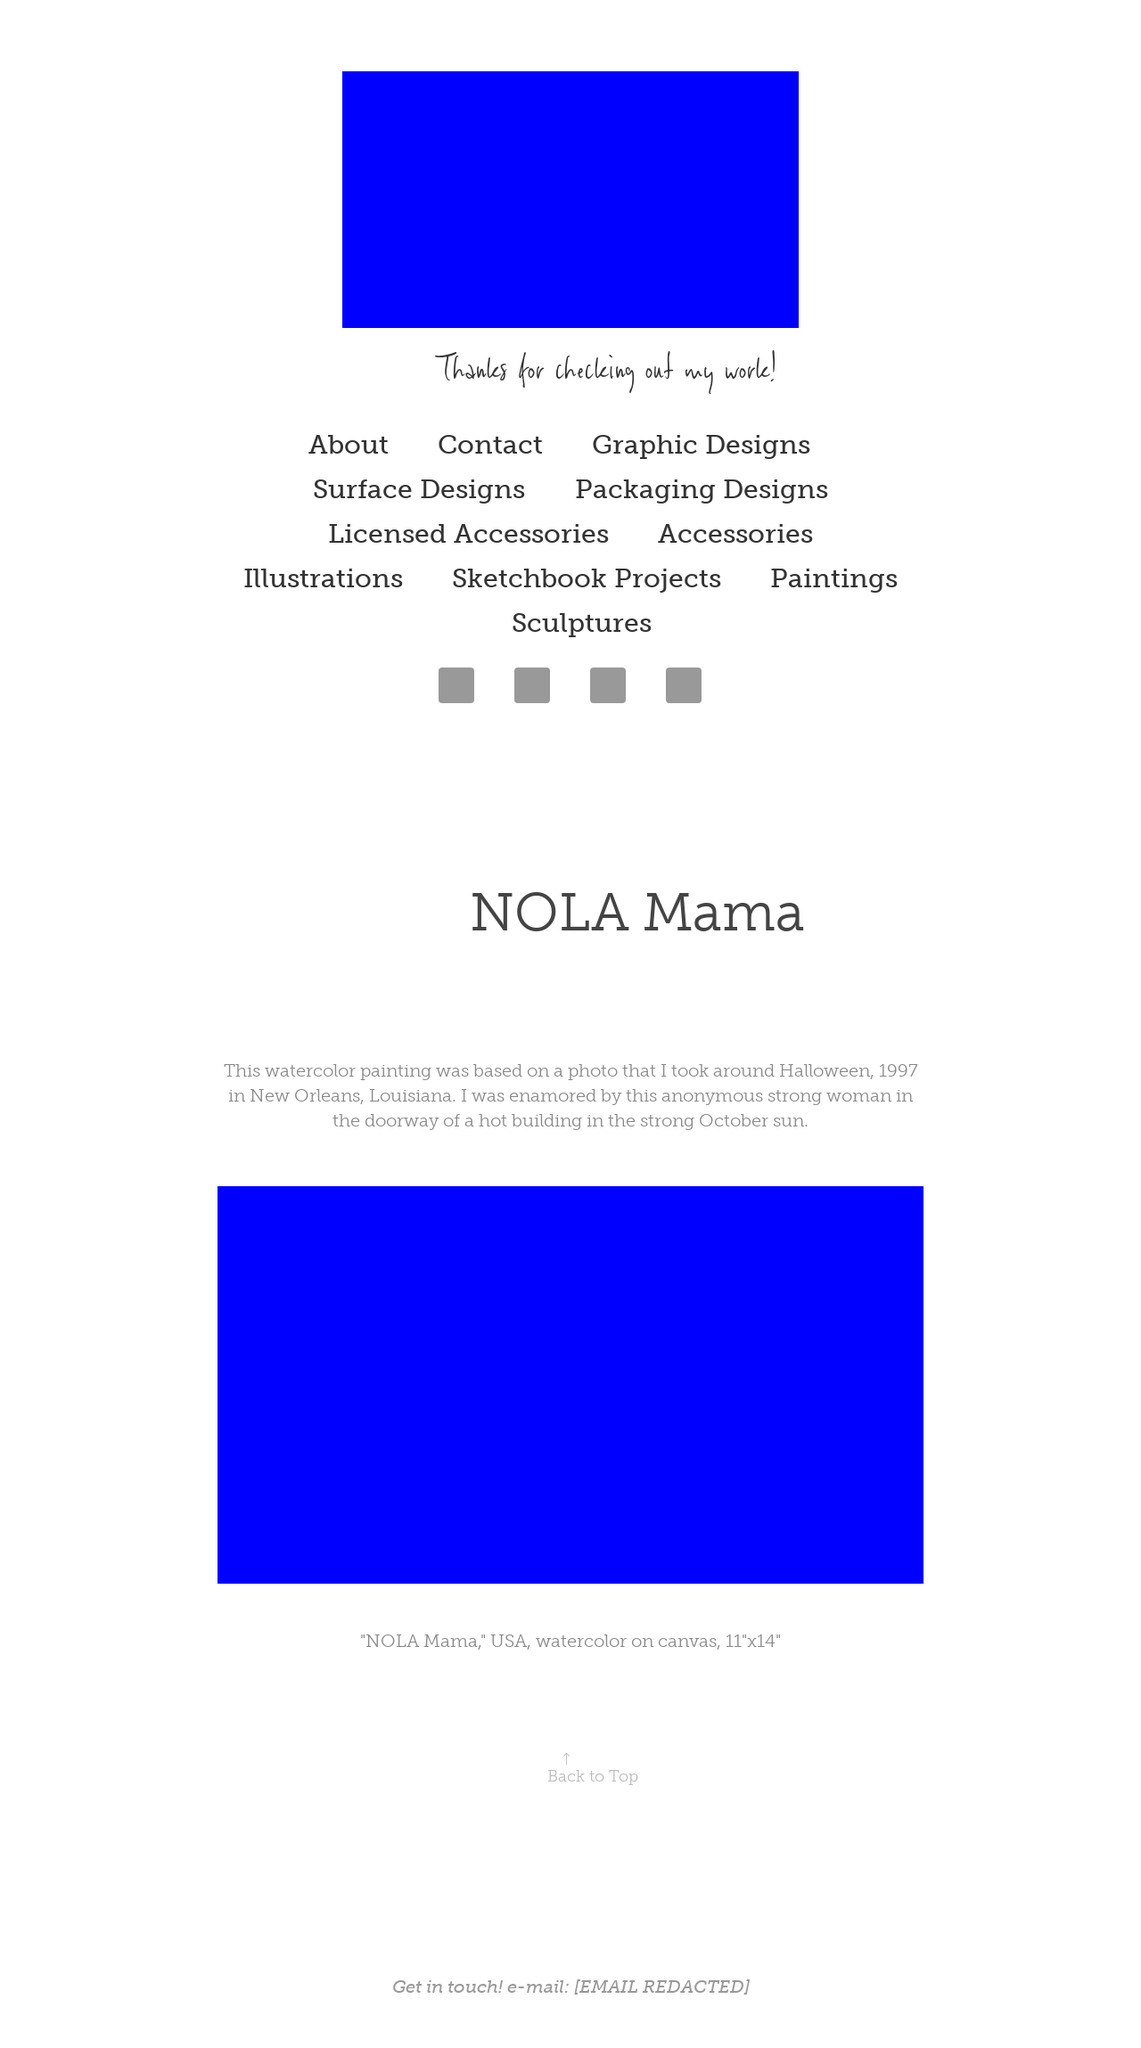What's the significance of preserving the story of 'NOLA Mama' on this website? Preserving the 'NOLA Mama' story on this website is significant as it extends beyond its artistic value, embedding a deep cultural and personal narrative within its expression. This painting is intimately linked to its roots in New Orleans, reflecting a specific moment and the resilience of its people during challenging times such as Hurricane Katrina. By showcasing this artwork online, the artist not only shares a personal memory but also highlights the broader narrative of survival, identity, and the power of community, thus enriching viewer understanding of the artwork's backstory and emotional depth. 